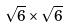<formula> <loc_0><loc_0><loc_500><loc_500>\sqrt { 6 } \times \sqrt { 6 }</formula> 